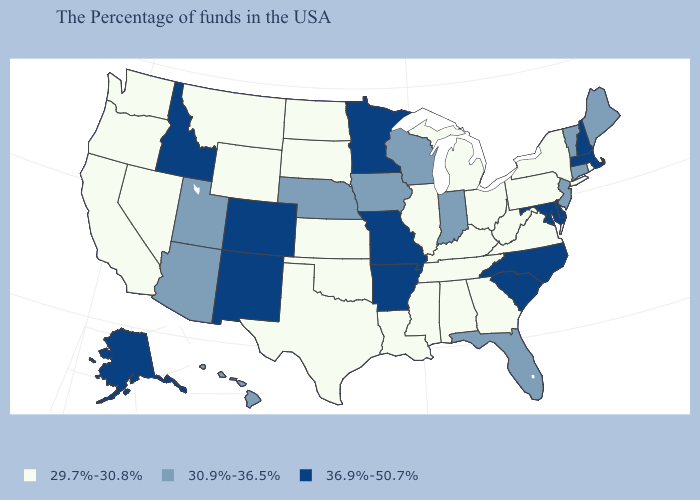Does the map have missing data?
Quick response, please. No. How many symbols are there in the legend?
Short answer required. 3. Does Pennsylvania have the lowest value in the Northeast?
Quick response, please. Yes. What is the highest value in the USA?
Quick response, please. 36.9%-50.7%. Does Florida have a lower value than Massachusetts?
Quick response, please. Yes. Name the states that have a value in the range 29.7%-30.8%?
Keep it brief. Rhode Island, New York, Pennsylvania, Virginia, West Virginia, Ohio, Georgia, Michigan, Kentucky, Alabama, Tennessee, Illinois, Mississippi, Louisiana, Kansas, Oklahoma, Texas, South Dakota, North Dakota, Wyoming, Montana, Nevada, California, Washington, Oregon. Which states have the highest value in the USA?
Answer briefly. Massachusetts, New Hampshire, Delaware, Maryland, North Carolina, South Carolina, Missouri, Arkansas, Minnesota, Colorado, New Mexico, Idaho, Alaska. Which states hav the highest value in the South?
Give a very brief answer. Delaware, Maryland, North Carolina, South Carolina, Arkansas. Does Maine have the same value as Connecticut?
Write a very short answer. Yes. Which states hav the highest value in the MidWest?
Write a very short answer. Missouri, Minnesota. Does the map have missing data?
Answer briefly. No. What is the value of Wisconsin?
Give a very brief answer. 30.9%-36.5%. What is the lowest value in the South?
Be succinct. 29.7%-30.8%. Which states hav the highest value in the West?
Be succinct. Colorado, New Mexico, Idaho, Alaska. Does Oregon have the highest value in the USA?
Be succinct. No. 